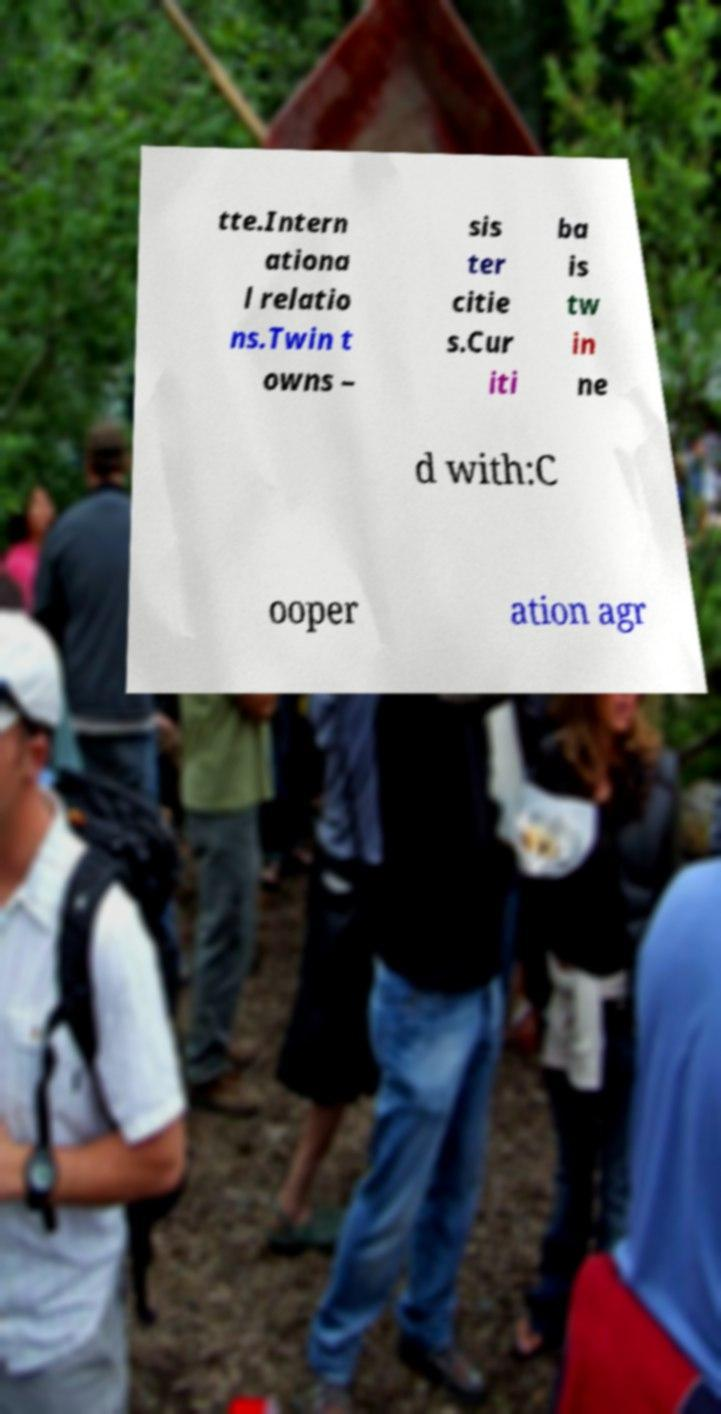Please identify and transcribe the text found in this image. tte.Intern ationa l relatio ns.Twin t owns – sis ter citie s.Cur iti ba is tw in ne d with:C ooper ation agr 